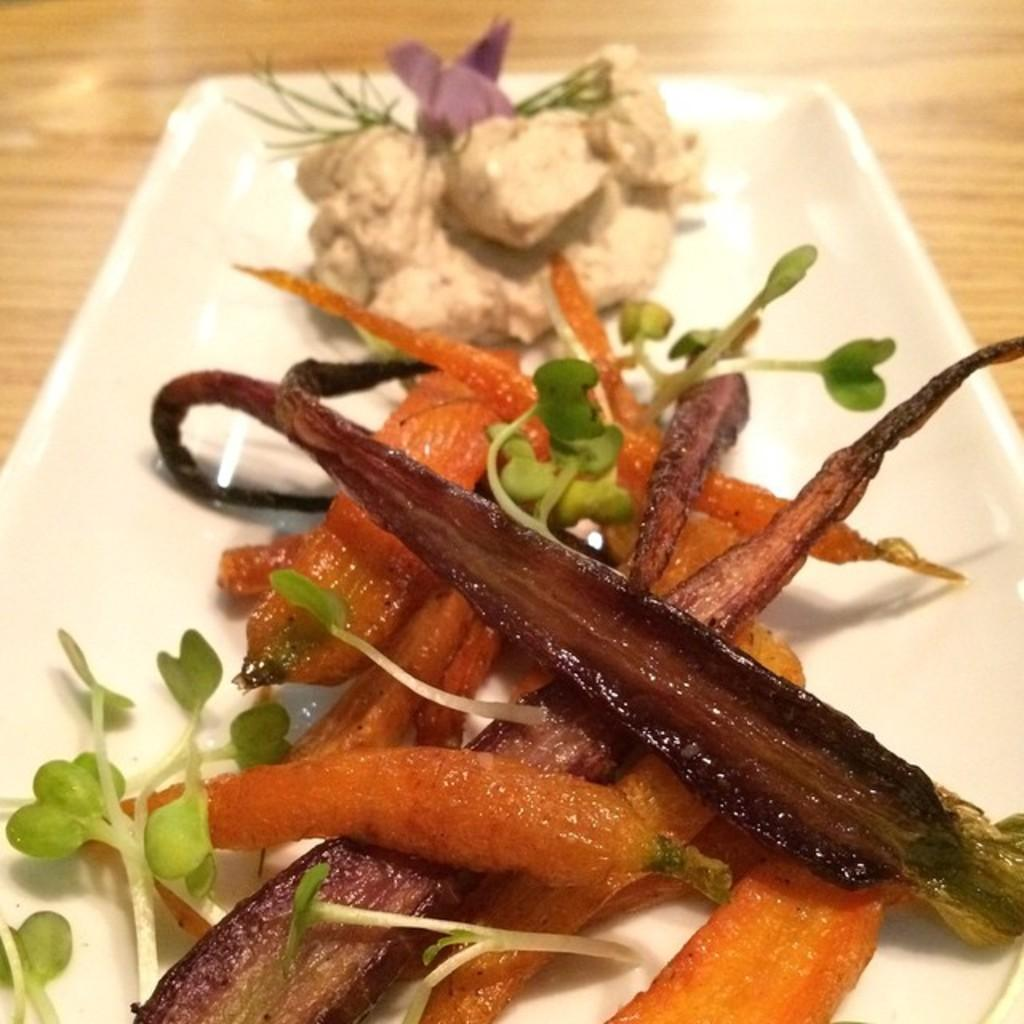What type of surface is visible in the image? There is a wooden surface in the image. What is placed on the wooden surface? There is a white plate on the wooden surface. What is on the white plate? The white plate contains food items. How many degrees does the boy have in the image? There is no boy present in the image, so it is not possible to determine how many degrees he might have. 